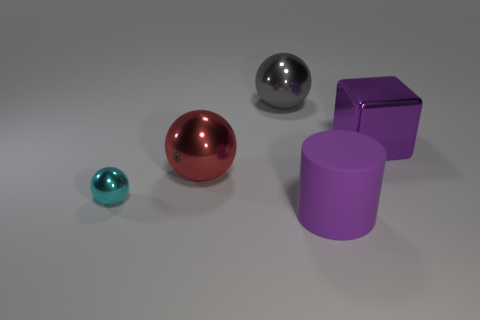What material is the cyan sphere?
Provide a short and direct response. Metal. Do the cyan ball that is on the left side of the metal cube and the red ball have the same material?
Ensure brevity in your answer.  Yes. Are there fewer gray metal objects that are on the right side of the large purple rubber cylinder than big red rubber cubes?
Make the answer very short. No. There is a cube that is the same size as the purple cylinder; what is its color?
Provide a succinct answer. Purple. How many big gray objects have the same shape as the purple rubber object?
Make the answer very short. 0. What color is the shiny sphere behind the red object?
Keep it short and to the point. Gray. What number of rubber things are tiny brown blocks or big cylinders?
Make the answer very short. 1. What shape is the object that is the same color as the metallic block?
Keep it short and to the point. Cylinder. What number of cubes have the same size as the red shiny thing?
Keep it short and to the point. 1. There is a big object that is both in front of the purple metal thing and behind the small sphere; what is its color?
Provide a short and direct response. Red. 